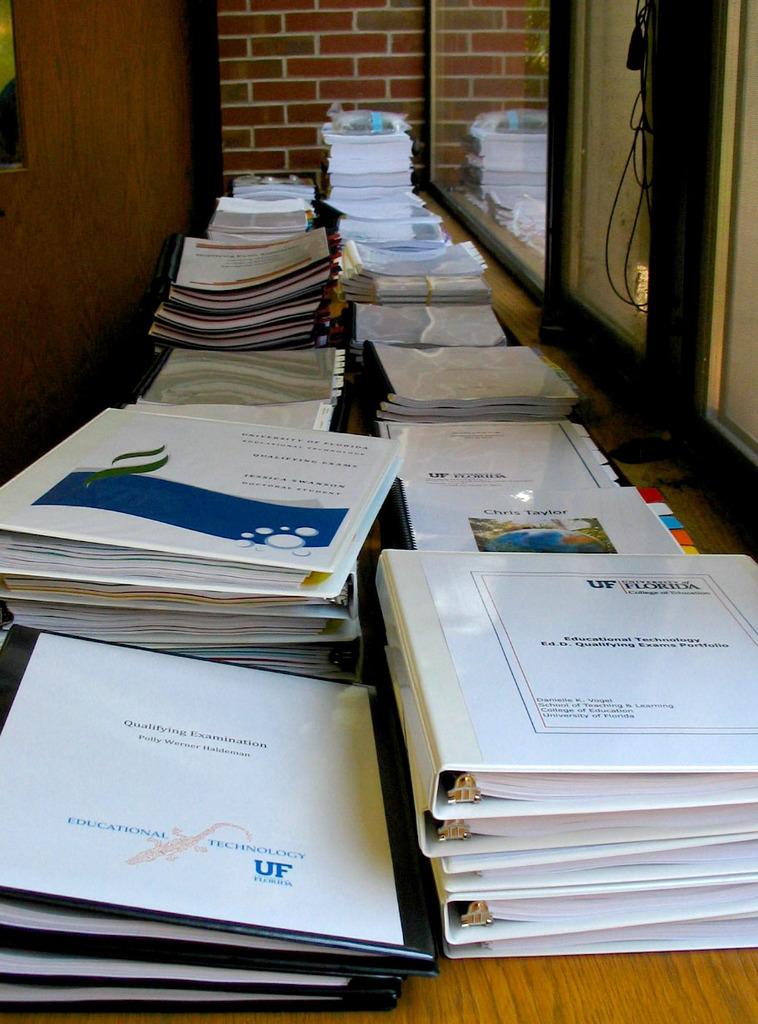What college is shown on the binders?
Ensure brevity in your answer.  University of florida. 